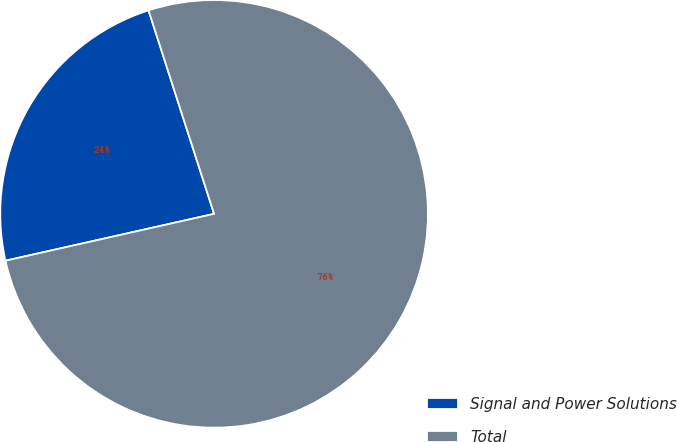Convert chart to OTSL. <chart><loc_0><loc_0><loc_500><loc_500><pie_chart><fcel>Signal and Power Solutions<fcel>Total<nl><fcel>23.56%<fcel>76.44%<nl></chart> 